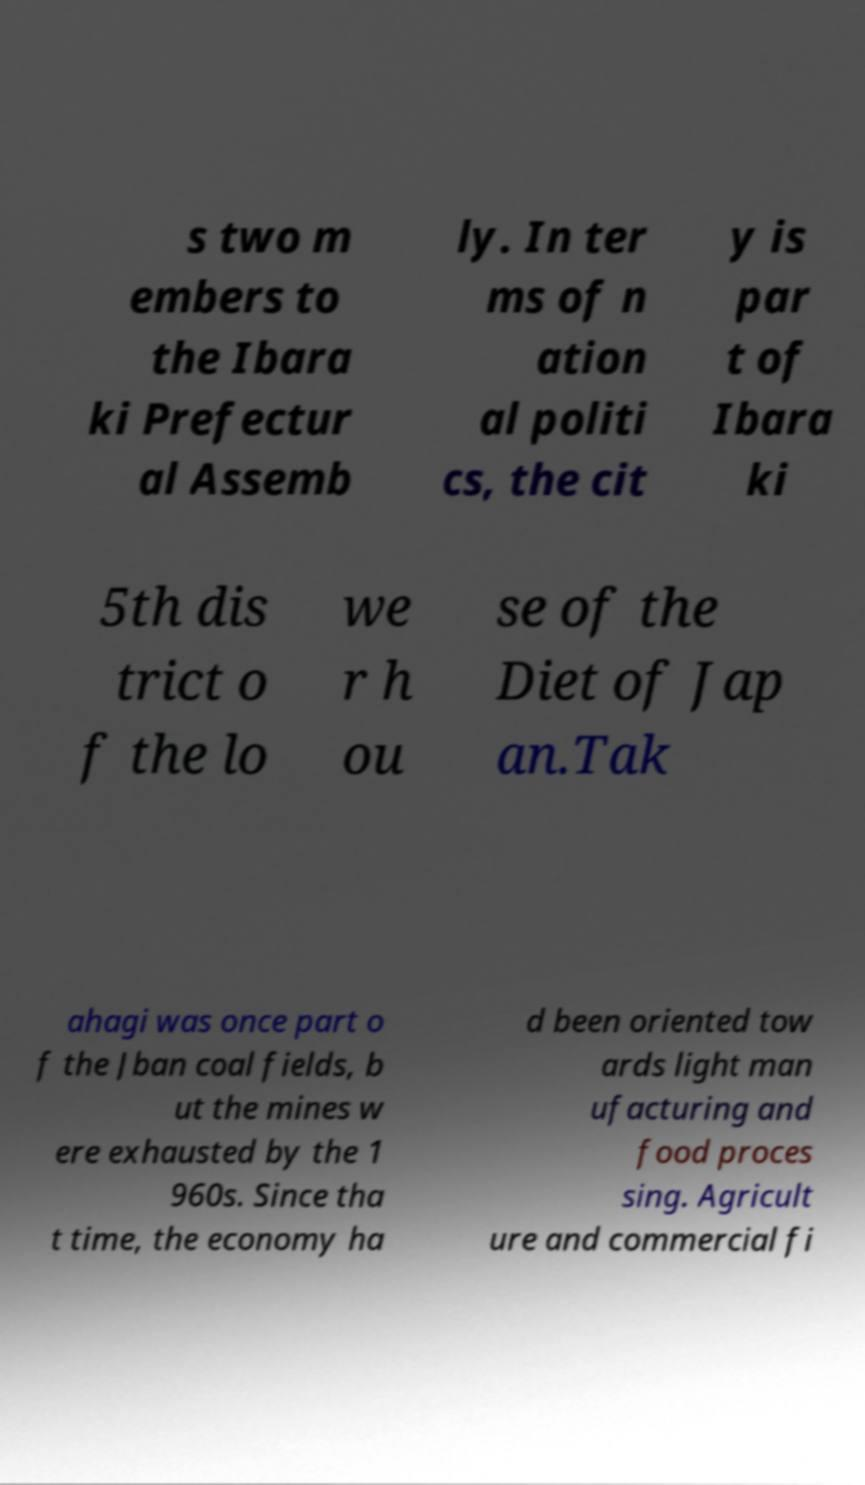Could you assist in decoding the text presented in this image and type it out clearly? s two m embers to the Ibara ki Prefectur al Assemb ly. In ter ms of n ation al politi cs, the cit y is par t of Ibara ki 5th dis trict o f the lo we r h ou se of the Diet of Jap an.Tak ahagi was once part o f the Jban coal fields, b ut the mines w ere exhausted by the 1 960s. Since tha t time, the economy ha d been oriented tow ards light man ufacturing and food proces sing. Agricult ure and commercial fi 